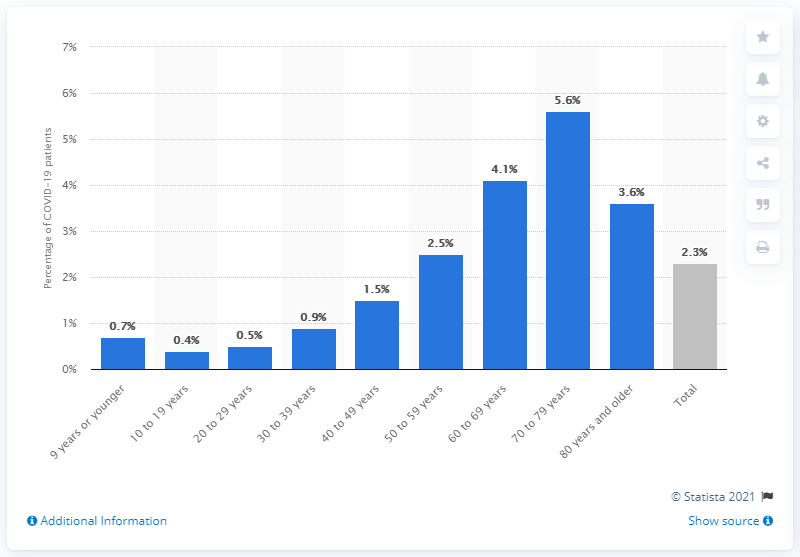Give some essential details in this illustration. In the age group of 70 to 79 years, among those who were diagnosed with COVID-19, 5.6% were admitted to the intensive care unit. 